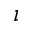<formula> <loc_0><loc_0><loc_500><loc_500>\imath</formula> 